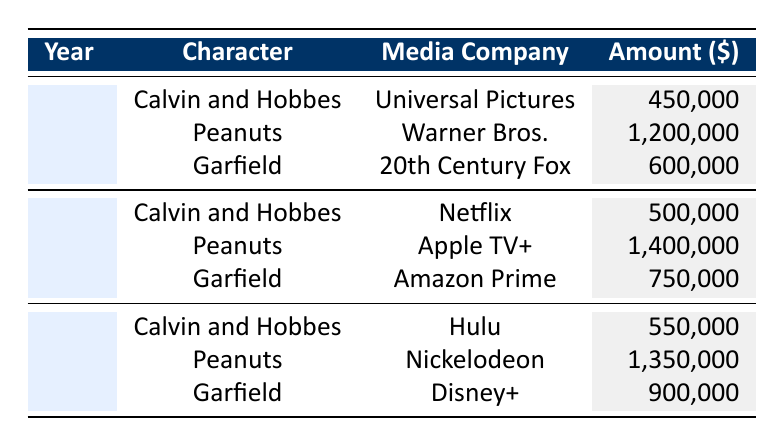What was the licensing fee collected for "Peanuts" in 2022? The table shows that for the character "Peanuts" in the year 2022, Apple TV+ was the media company, and the amount collected was 1,400,000.
Answer: 1,400,000 Which media company paid the highest licensing fee for "Calvin and Hobbes" in 2023? In 2023, the licensing fee for "Calvin and Hobbes" was paid by Hulu, which collected 550,000. Looking at the other years, Universal Pictures paid 450,000 in 2021 and Netflix paid 500,000 in 2022. Thus, Hulu had the highest payment for that year.
Answer: Hulu What was the total amount collected from "Garfield" across all three years? To find the total for "Garfield", we add the amounts collected over the three years: 600,000 (2021) + 750,000 (2022) + 900,000 (2023) = 2,250,000.
Answer: 2,250,000 Did "Peanuts" generate more licensing fees in 2021 or 2023? In 2021, the fee collected for "Peanuts" was 1,200,000, while in 2023, it was 1,350,000. Since 1,350,000 is greater than 1,200,000, Peanuts generated more fees in 2023.
Answer: Yes What is the average licensing fee collected for "Calvin and Hobbes" over the three years? For "Calvin and Hobbes," the amounts collected are 450,000 (2021), 500,000 (2022), and 550,000 (2023). Summing these gives 450,000 + 500,000 + 550,000 = 1,500,000. To find the average, divide by 3 (the number of years): 1,500,000 / 3 = 500,000.
Answer: 500,000 Which character received the lowest licensing fee in 2021? In 2021, the amounts collected for "Calvin and Hobbes," "Peanuts," and "Garfield" were 450,000, 1,200,000, and 600,000, respectively. The lowest amount among these is 450,000 for "Calvin and Hobbes."
Answer: Calvin and Hobbes What is the difference in licensing fees collected for "Peanuts" between 2022 and 2023? In 2022, "Peanuts" generated 1,400,000, while in 2023 it generated 1,350,000. The difference is calculated as 1,400,000 - 1,350,000 = 50,000.
Answer: 50,000 Was the amount collected for "Garfield" higher in 2022 than in 2021? In 2021, "Garfield" collected 600,000, and in 2022, it collected 750,000. Since 750,000 is greater than 600,000, the amount was higher in 2022.
Answer: Yes 